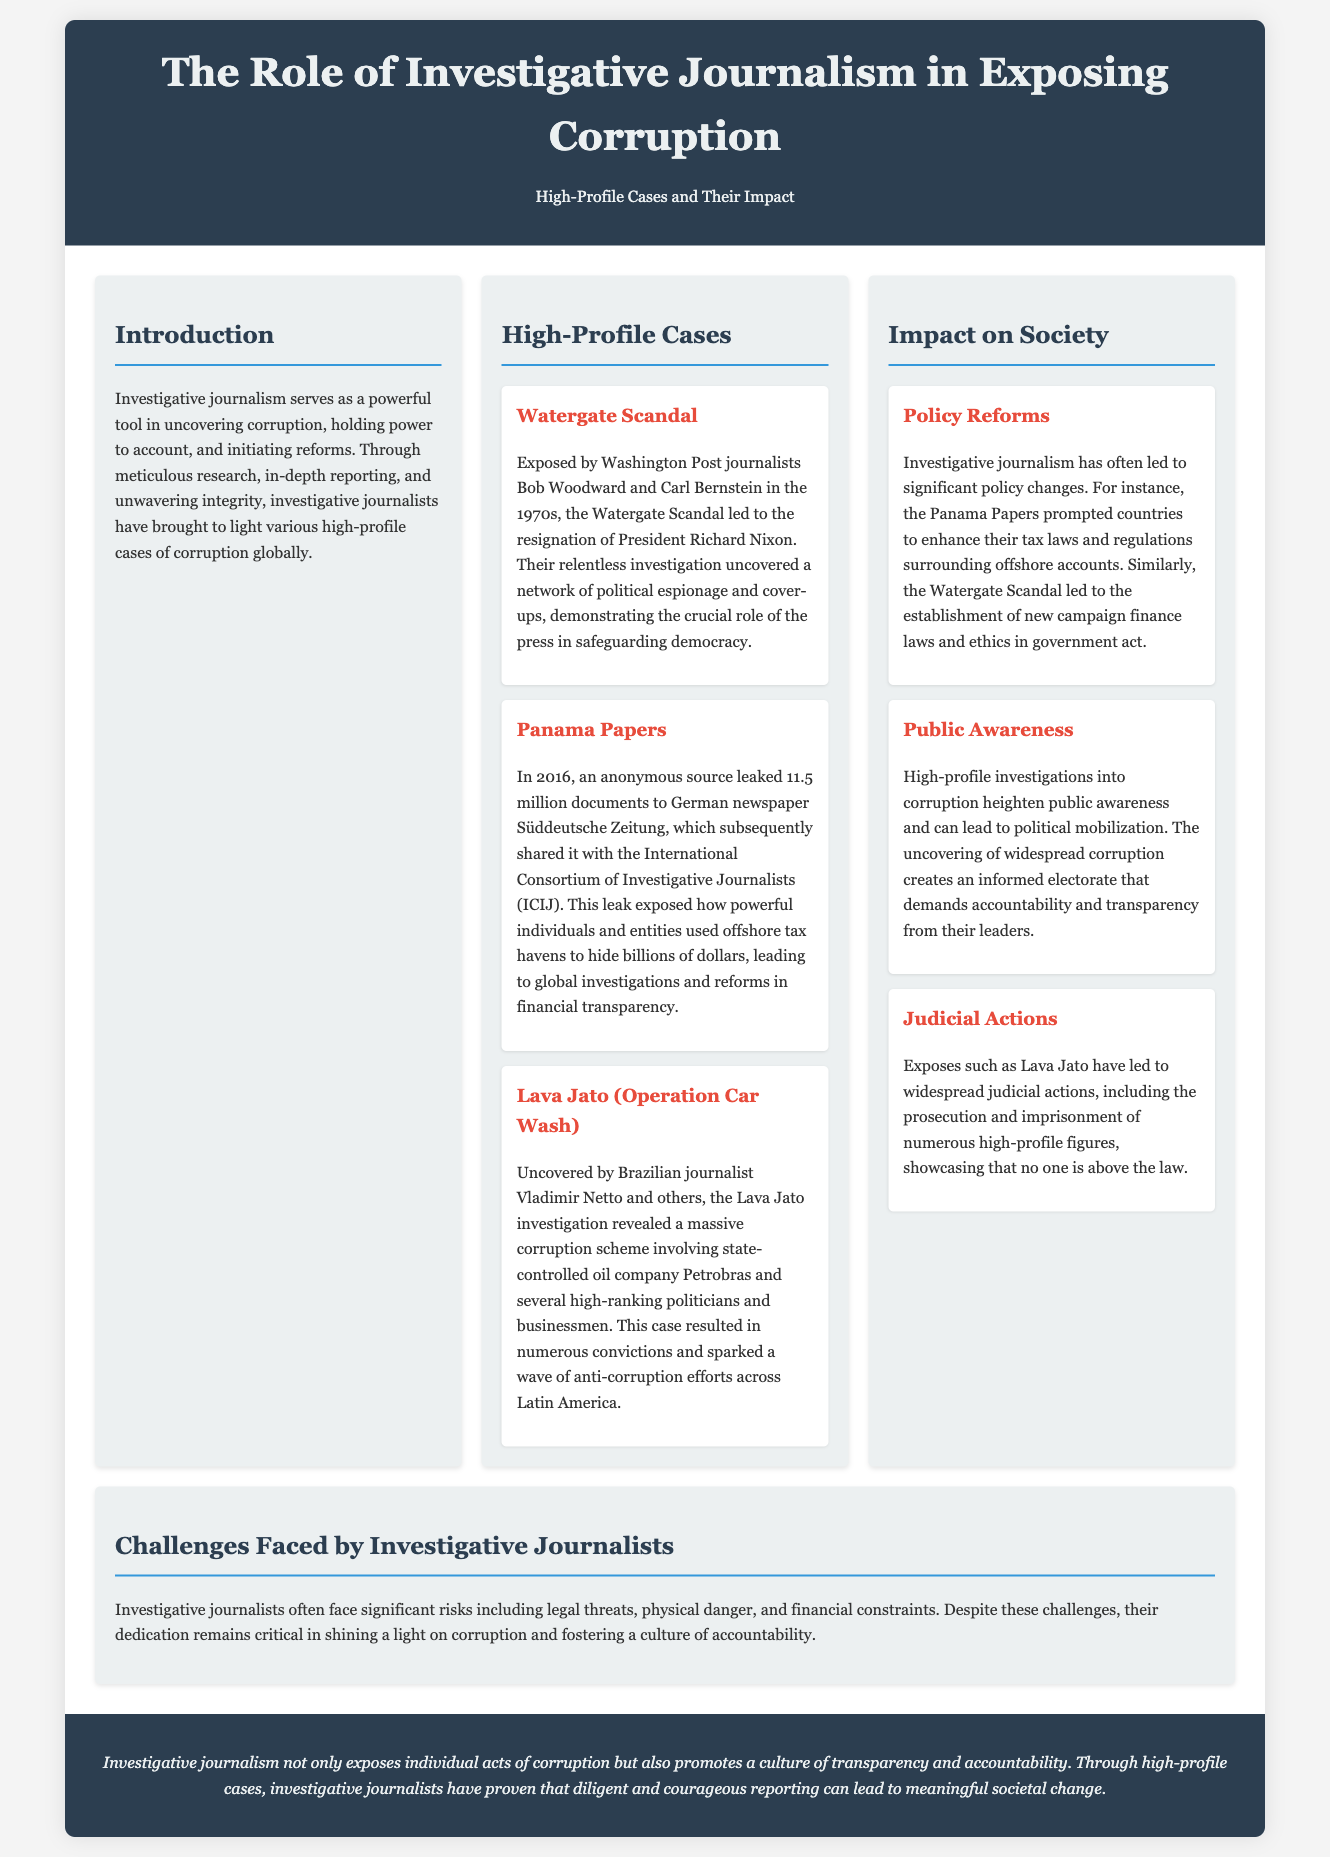What was the role of Bob Woodward and Carl Bernstein? They were Washington Post journalists who exposed the Watergate Scandal in the 1970s.
Answer: Washington Post journalists In what year was the Panama Papers leak? The Panama Papers leak occurred in 2016 when 11.5 million documents were leaked.
Answer: 2016 What significant outcome did the Lava Jato investigation lead to in Latin America? The investigation sparked a wave of anti-corruption efforts across Latin America.
Answer: Anti-corruption efforts What two types of societal impact does investigative journalism aim to achieve? Investigative journalism aims to promote accountability and transparency in society.
Answer: Accountability and transparency What is a major challenge faced by investigative journalists? Investigative journalists face risks such as legal threats.
Answer: Legal threats 